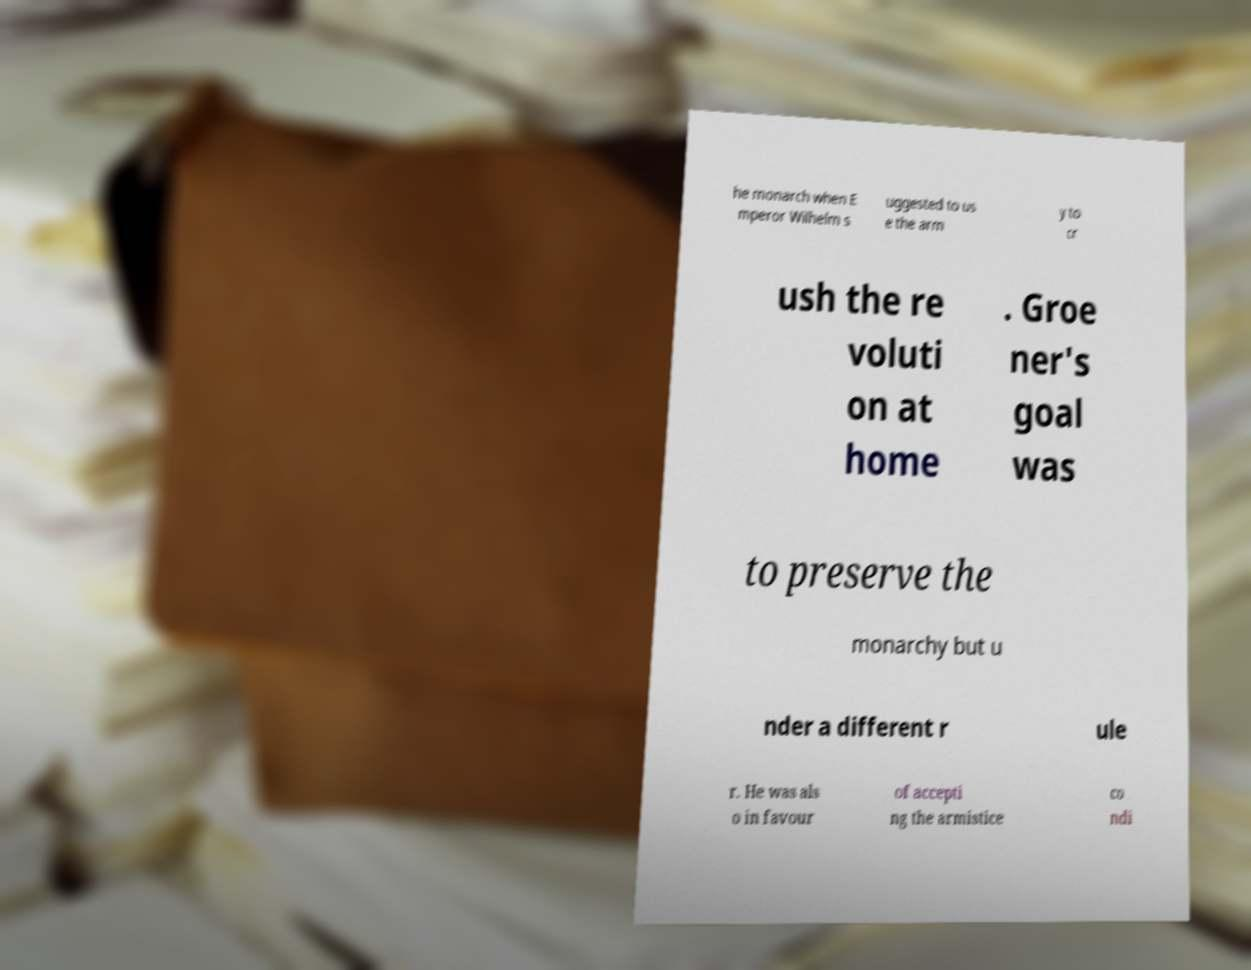For documentation purposes, I need the text within this image transcribed. Could you provide that? he monarch when E mperor Wilhelm s uggested to us e the arm y to cr ush the re voluti on at home . Groe ner's goal was to preserve the monarchy but u nder a different r ule r. He was als o in favour of accepti ng the armistice co ndi 